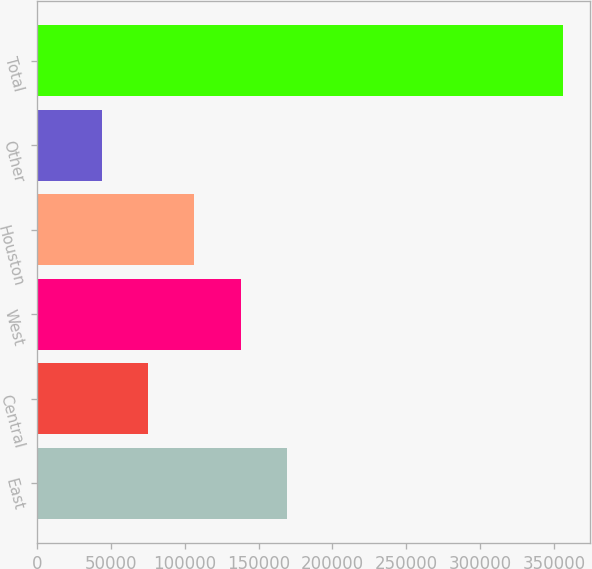Convert chart. <chart><loc_0><loc_0><loc_500><loc_500><bar_chart><fcel>East<fcel>Central<fcel>West<fcel>Houston<fcel>Other<fcel>Total<nl><fcel>169019<fcel>75284.7<fcel>137774<fcel>106529<fcel>44040<fcel>356487<nl></chart> 